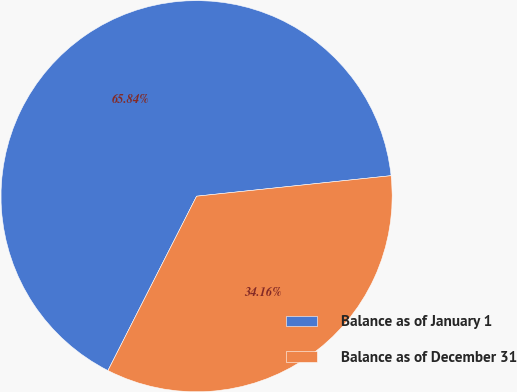<chart> <loc_0><loc_0><loc_500><loc_500><pie_chart><fcel>Balance as of January 1<fcel>Balance as of December 31<nl><fcel>65.84%<fcel>34.16%<nl></chart> 